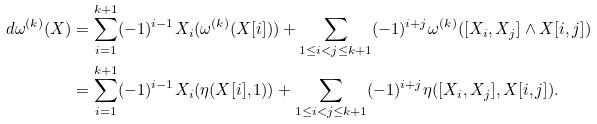Convert formula to latex. <formula><loc_0><loc_0><loc_500><loc_500>d \omega ^ { ( k ) } ( X ) & = \sum _ { i = 1 } ^ { k + 1 } ( - 1 ) ^ { i - 1 } X _ { i } ( \omega ^ { ( k ) } ( X [ i ] ) ) + \sum _ { 1 \leq i < j \leq k + 1 } ( - 1 ) ^ { i + j } \omega ^ { ( k ) } ( [ X _ { i } , X _ { j } ] \wedge X [ i , j ] ) \\ & = \sum _ { i = 1 } ^ { k + 1 } ( - 1 ) ^ { i - 1 } X _ { i } ( \eta ( X [ i ] , 1 ) ) + \sum _ { 1 \leq i < j \leq k + 1 } ( - 1 ) ^ { i + j } \eta ( [ X _ { i } , X _ { j } ] , X [ i , j ] ) .</formula> 